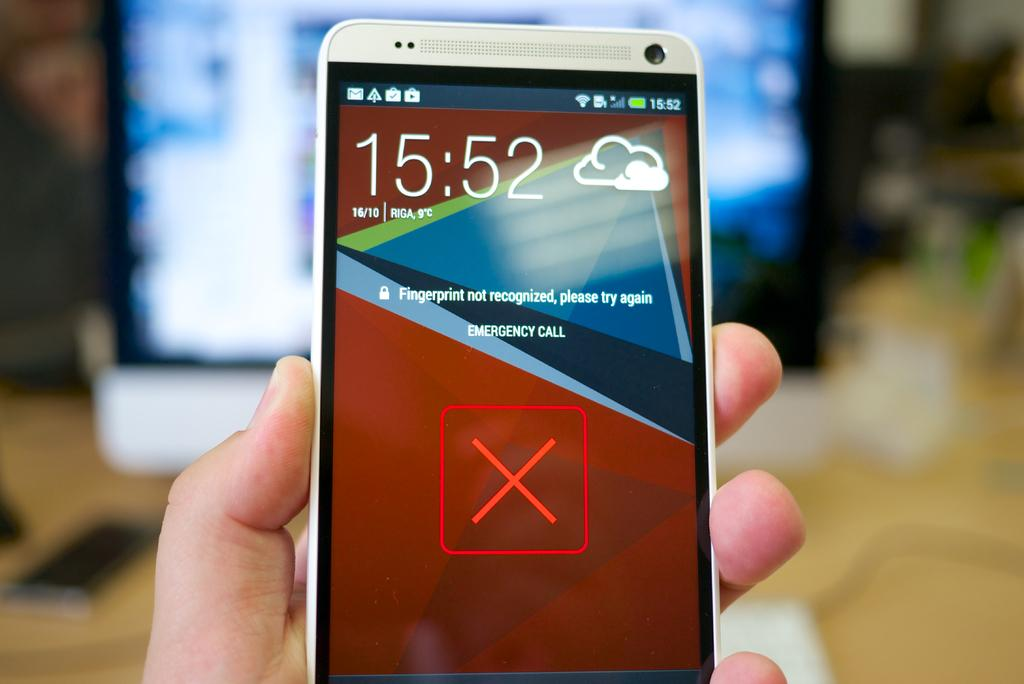Provide a one-sentence caption for the provided image. A cell phone informs the user the finger print was not recognized. 